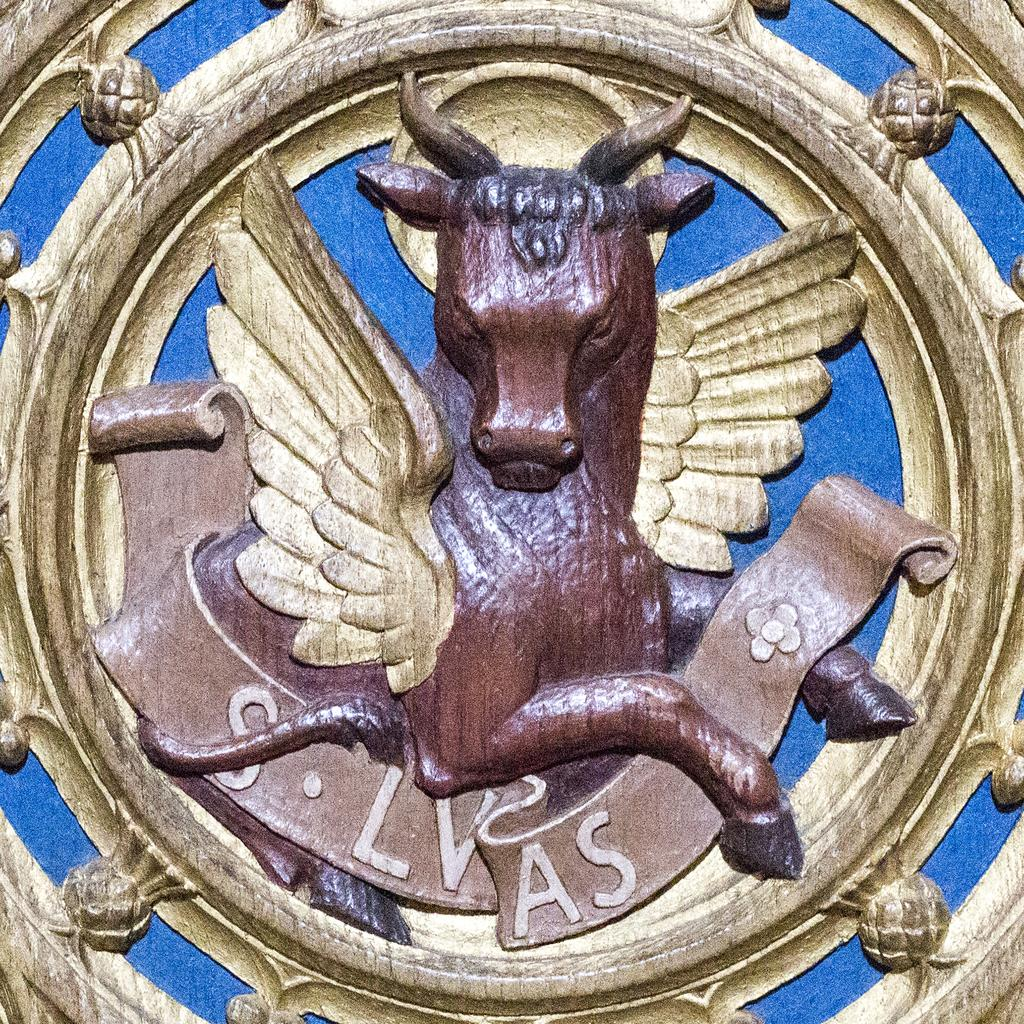What is the main feature of the image? There is a logo in the image. Can you describe the animal in the logo? The animal in the logo is brown, and its wings are in gold color. What is the color of the background in the logo? The background of the logo is blue. How many keys are used to unlock the pot in the image? There are no keys or pots present in the image; it only contains a logo with an animal and a blue background. 